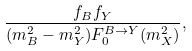Convert formula to latex. <formula><loc_0><loc_0><loc_500><loc_500>\frac { f _ { B } f _ { Y } } { ( m _ { B } ^ { 2 } - m _ { Y } ^ { 2 } ) F _ { 0 } ^ { B \to Y } ( m _ { X } ^ { 2 } ) } ,</formula> 